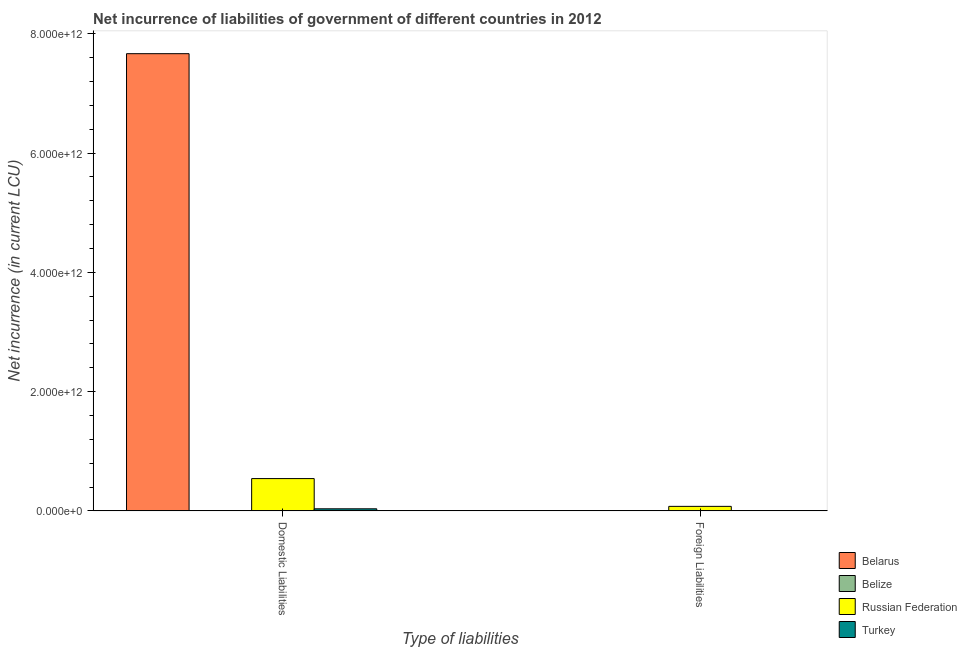How many different coloured bars are there?
Make the answer very short. 4. Are the number of bars per tick equal to the number of legend labels?
Ensure brevity in your answer.  No. How many bars are there on the 1st tick from the left?
Provide a succinct answer. 4. How many bars are there on the 2nd tick from the right?
Give a very brief answer. 4. What is the label of the 2nd group of bars from the left?
Offer a terse response. Foreign Liabilities. What is the net incurrence of domestic liabilities in Turkey?
Provide a short and direct response. 3.49e+1. Across all countries, what is the maximum net incurrence of domestic liabilities?
Offer a very short reply. 7.67e+12. Across all countries, what is the minimum net incurrence of foreign liabilities?
Provide a succinct answer. 0. In which country was the net incurrence of foreign liabilities maximum?
Give a very brief answer. Russian Federation. What is the total net incurrence of domestic liabilities in the graph?
Give a very brief answer. 8.24e+12. What is the difference between the net incurrence of domestic liabilities in Russian Federation and that in Belarus?
Provide a succinct answer. -7.12e+12. What is the difference between the net incurrence of domestic liabilities in Russian Federation and the net incurrence of foreign liabilities in Turkey?
Offer a very short reply. 5.36e+11. What is the average net incurrence of foreign liabilities per country?
Your answer should be very brief. 2.04e+1. What is the difference between the net incurrence of foreign liabilities and net incurrence of domestic liabilities in Belize?
Give a very brief answer. 3.52e+07. In how many countries, is the net incurrence of domestic liabilities greater than 3200000000000 LCU?
Ensure brevity in your answer.  1. What is the ratio of the net incurrence of domestic liabilities in Belize to that in Russian Federation?
Ensure brevity in your answer.  1.1212848440095993e-5. Is the net incurrence of foreign liabilities in Belize less than that in Turkey?
Give a very brief answer. Yes. In how many countries, is the net incurrence of foreign liabilities greater than the average net incurrence of foreign liabilities taken over all countries?
Ensure brevity in your answer.  1. How many bars are there?
Ensure brevity in your answer.  7. What is the difference between two consecutive major ticks on the Y-axis?
Your answer should be very brief. 2.00e+12. Are the values on the major ticks of Y-axis written in scientific E-notation?
Make the answer very short. Yes. Does the graph contain any zero values?
Your answer should be very brief. Yes. Where does the legend appear in the graph?
Provide a succinct answer. Bottom right. What is the title of the graph?
Your answer should be compact. Net incurrence of liabilities of government of different countries in 2012. What is the label or title of the X-axis?
Keep it short and to the point. Type of liabilities. What is the label or title of the Y-axis?
Offer a terse response. Net incurrence (in current LCU). What is the Net incurrence (in current LCU) in Belarus in Domestic Liabilities?
Your response must be concise. 7.67e+12. What is the Net incurrence (in current LCU) in Belize in Domestic Liabilities?
Your answer should be compact. 6.07e+06. What is the Net incurrence (in current LCU) in Russian Federation in Domestic Liabilities?
Provide a succinct answer. 5.42e+11. What is the Net incurrence (in current LCU) of Turkey in Domestic Liabilities?
Ensure brevity in your answer.  3.49e+1. What is the Net incurrence (in current LCU) in Belize in Foreign Liabilities?
Offer a very short reply. 4.13e+07. What is the Net incurrence (in current LCU) in Russian Federation in Foreign Liabilities?
Provide a succinct answer. 7.58e+1. What is the Net incurrence (in current LCU) in Turkey in Foreign Liabilities?
Provide a short and direct response. 5.76e+09. Across all Type of liabilities, what is the maximum Net incurrence (in current LCU) of Belarus?
Make the answer very short. 7.67e+12. Across all Type of liabilities, what is the maximum Net incurrence (in current LCU) in Belize?
Offer a terse response. 4.13e+07. Across all Type of liabilities, what is the maximum Net incurrence (in current LCU) of Russian Federation?
Your response must be concise. 5.42e+11. Across all Type of liabilities, what is the maximum Net incurrence (in current LCU) of Turkey?
Provide a short and direct response. 3.49e+1. Across all Type of liabilities, what is the minimum Net incurrence (in current LCU) in Belize?
Ensure brevity in your answer.  6.07e+06. Across all Type of liabilities, what is the minimum Net incurrence (in current LCU) of Russian Federation?
Offer a very short reply. 7.58e+1. Across all Type of liabilities, what is the minimum Net incurrence (in current LCU) of Turkey?
Your answer should be compact. 5.76e+09. What is the total Net incurrence (in current LCU) of Belarus in the graph?
Offer a very short reply. 7.67e+12. What is the total Net incurrence (in current LCU) of Belize in the graph?
Offer a terse response. 4.74e+07. What is the total Net incurrence (in current LCU) in Russian Federation in the graph?
Offer a terse response. 6.18e+11. What is the total Net incurrence (in current LCU) of Turkey in the graph?
Provide a short and direct response. 4.07e+1. What is the difference between the Net incurrence (in current LCU) of Belize in Domestic Liabilities and that in Foreign Liabilities?
Your response must be concise. -3.52e+07. What is the difference between the Net incurrence (in current LCU) in Russian Federation in Domestic Liabilities and that in Foreign Liabilities?
Your response must be concise. 4.66e+11. What is the difference between the Net incurrence (in current LCU) in Turkey in Domestic Liabilities and that in Foreign Liabilities?
Your answer should be compact. 2.91e+1. What is the difference between the Net incurrence (in current LCU) of Belarus in Domestic Liabilities and the Net incurrence (in current LCU) of Belize in Foreign Liabilities?
Your answer should be compact. 7.67e+12. What is the difference between the Net incurrence (in current LCU) in Belarus in Domestic Liabilities and the Net incurrence (in current LCU) in Russian Federation in Foreign Liabilities?
Your answer should be compact. 7.59e+12. What is the difference between the Net incurrence (in current LCU) in Belarus in Domestic Liabilities and the Net incurrence (in current LCU) in Turkey in Foreign Liabilities?
Your answer should be very brief. 7.66e+12. What is the difference between the Net incurrence (in current LCU) of Belize in Domestic Liabilities and the Net incurrence (in current LCU) of Russian Federation in Foreign Liabilities?
Give a very brief answer. -7.58e+1. What is the difference between the Net incurrence (in current LCU) of Belize in Domestic Liabilities and the Net incurrence (in current LCU) of Turkey in Foreign Liabilities?
Provide a succinct answer. -5.75e+09. What is the difference between the Net incurrence (in current LCU) in Russian Federation in Domestic Liabilities and the Net incurrence (in current LCU) in Turkey in Foreign Liabilities?
Keep it short and to the point. 5.36e+11. What is the average Net incurrence (in current LCU) of Belarus per Type of liabilities?
Your answer should be compact. 3.83e+12. What is the average Net incurrence (in current LCU) of Belize per Type of liabilities?
Your response must be concise. 2.37e+07. What is the average Net incurrence (in current LCU) in Russian Federation per Type of liabilities?
Provide a succinct answer. 3.09e+11. What is the average Net incurrence (in current LCU) of Turkey per Type of liabilities?
Give a very brief answer. 2.03e+1. What is the difference between the Net incurrence (in current LCU) in Belarus and Net incurrence (in current LCU) in Belize in Domestic Liabilities?
Your answer should be compact. 7.67e+12. What is the difference between the Net incurrence (in current LCU) of Belarus and Net incurrence (in current LCU) of Russian Federation in Domestic Liabilities?
Offer a terse response. 7.12e+12. What is the difference between the Net incurrence (in current LCU) of Belarus and Net incurrence (in current LCU) of Turkey in Domestic Liabilities?
Offer a terse response. 7.63e+12. What is the difference between the Net incurrence (in current LCU) of Belize and Net incurrence (in current LCU) of Russian Federation in Domestic Liabilities?
Offer a very short reply. -5.42e+11. What is the difference between the Net incurrence (in current LCU) in Belize and Net incurrence (in current LCU) in Turkey in Domestic Liabilities?
Make the answer very short. -3.49e+1. What is the difference between the Net incurrence (in current LCU) of Russian Federation and Net incurrence (in current LCU) of Turkey in Domestic Liabilities?
Provide a succinct answer. 5.07e+11. What is the difference between the Net incurrence (in current LCU) in Belize and Net incurrence (in current LCU) in Russian Federation in Foreign Liabilities?
Offer a terse response. -7.58e+1. What is the difference between the Net incurrence (in current LCU) of Belize and Net incurrence (in current LCU) of Turkey in Foreign Liabilities?
Offer a very short reply. -5.71e+09. What is the difference between the Net incurrence (in current LCU) of Russian Federation and Net incurrence (in current LCU) of Turkey in Foreign Liabilities?
Your response must be concise. 7.00e+1. What is the ratio of the Net incurrence (in current LCU) of Belize in Domestic Liabilities to that in Foreign Liabilities?
Provide a succinct answer. 0.15. What is the ratio of the Net incurrence (in current LCU) in Russian Federation in Domestic Liabilities to that in Foreign Liabilities?
Offer a terse response. 7.15. What is the ratio of the Net incurrence (in current LCU) in Turkey in Domestic Liabilities to that in Foreign Liabilities?
Your response must be concise. 6.06. What is the difference between the highest and the second highest Net incurrence (in current LCU) in Belize?
Offer a very short reply. 3.52e+07. What is the difference between the highest and the second highest Net incurrence (in current LCU) of Russian Federation?
Your answer should be compact. 4.66e+11. What is the difference between the highest and the second highest Net incurrence (in current LCU) in Turkey?
Ensure brevity in your answer.  2.91e+1. What is the difference between the highest and the lowest Net incurrence (in current LCU) of Belarus?
Your answer should be compact. 7.67e+12. What is the difference between the highest and the lowest Net incurrence (in current LCU) of Belize?
Provide a succinct answer. 3.52e+07. What is the difference between the highest and the lowest Net incurrence (in current LCU) of Russian Federation?
Offer a very short reply. 4.66e+11. What is the difference between the highest and the lowest Net incurrence (in current LCU) of Turkey?
Ensure brevity in your answer.  2.91e+1. 